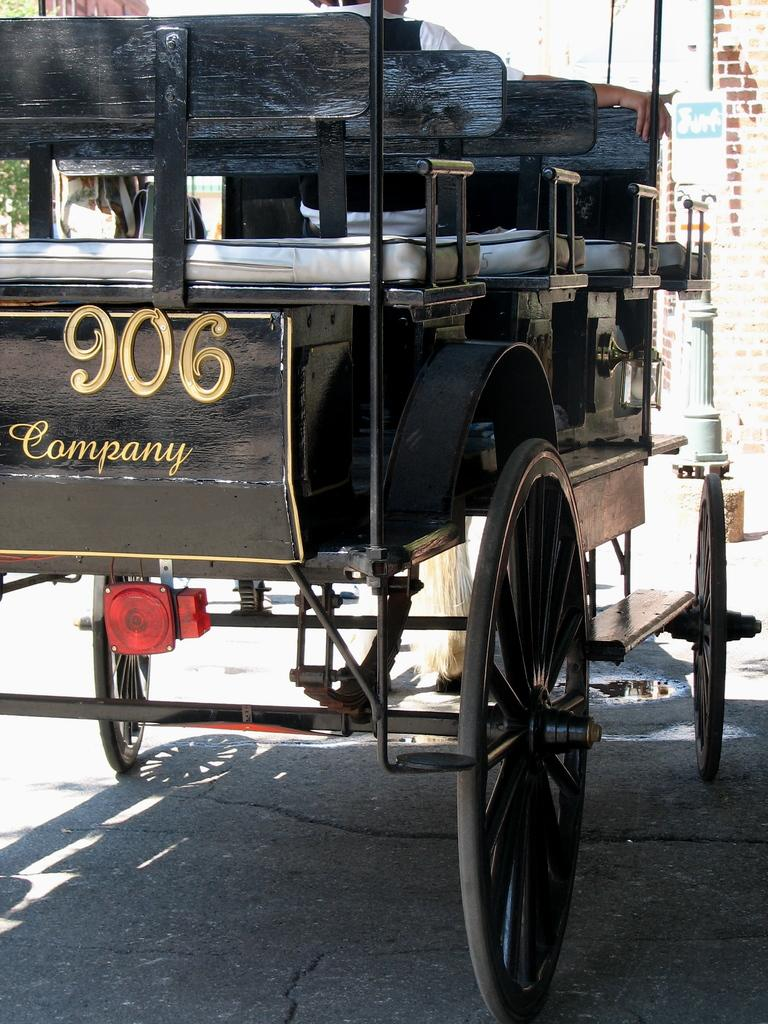What is the main object in the image? There is a cart in the image. Who or what is in the cart? A person is present in the cart. What can be seen on the cart? There is some text visible on the cart. What is the ground like in the image? The ground is visible in the image. What else can be seen in the image besides the cart? There is a pole with a poster and a wall visible in the image. What type of toy is the person playing with in the image? There is no toy present in the image; the person is in a cart. 